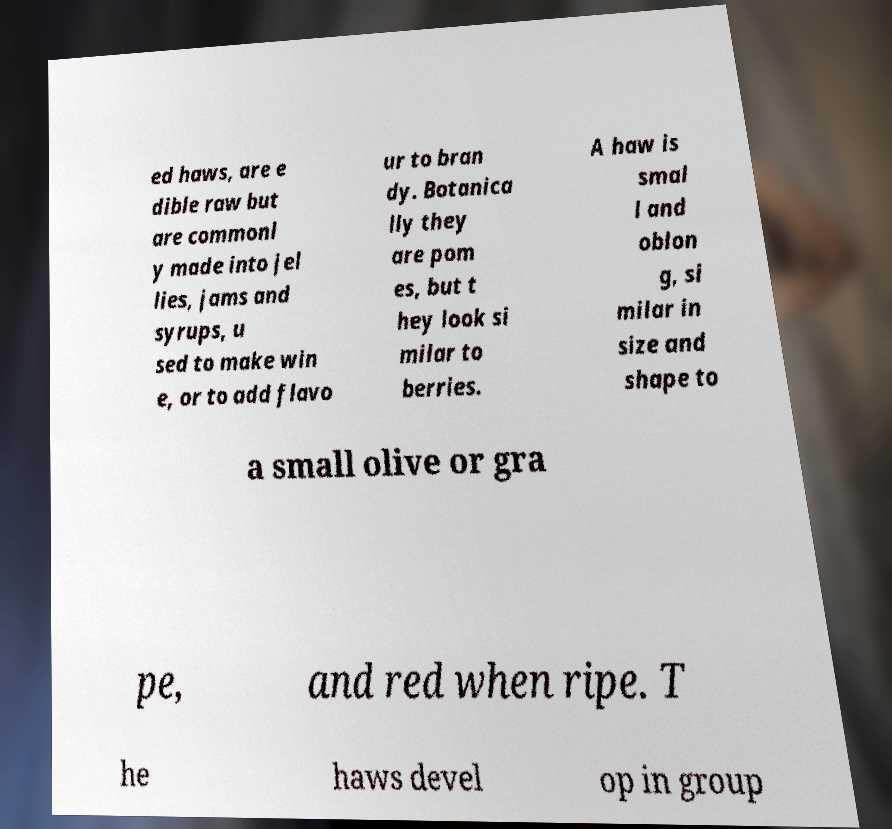For documentation purposes, I need the text within this image transcribed. Could you provide that? ed haws, are e dible raw but are commonl y made into jel lies, jams and syrups, u sed to make win e, or to add flavo ur to bran dy. Botanica lly they are pom es, but t hey look si milar to berries. A haw is smal l and oblon g, si milar in size and shape to a small olive or gra pe, and red when ripe. T he haws devel op in group 